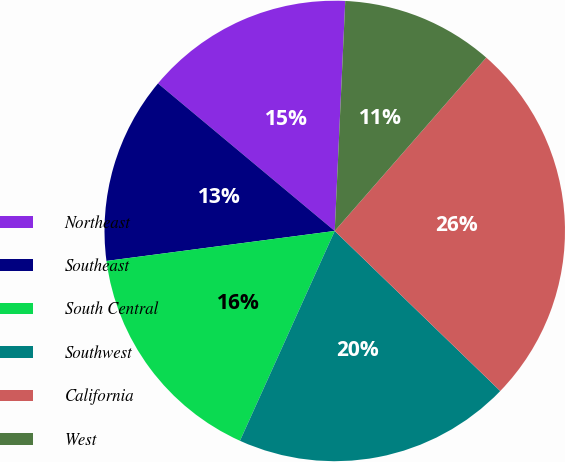Convert chart to OTSL. <chart><loc_0><loc_0><loc_500><loc_500><pie_chart><fcel>Northeast<fcel>Southeast<fcel>South Central<fcel>Southwest<fcel>California<fcel>West<nl><fcel>14.66%<fcel>13.15%<fcel>16.17%<fcel>19.52%<fcel>25.81%<fcel>10.7%<nl></chart> 